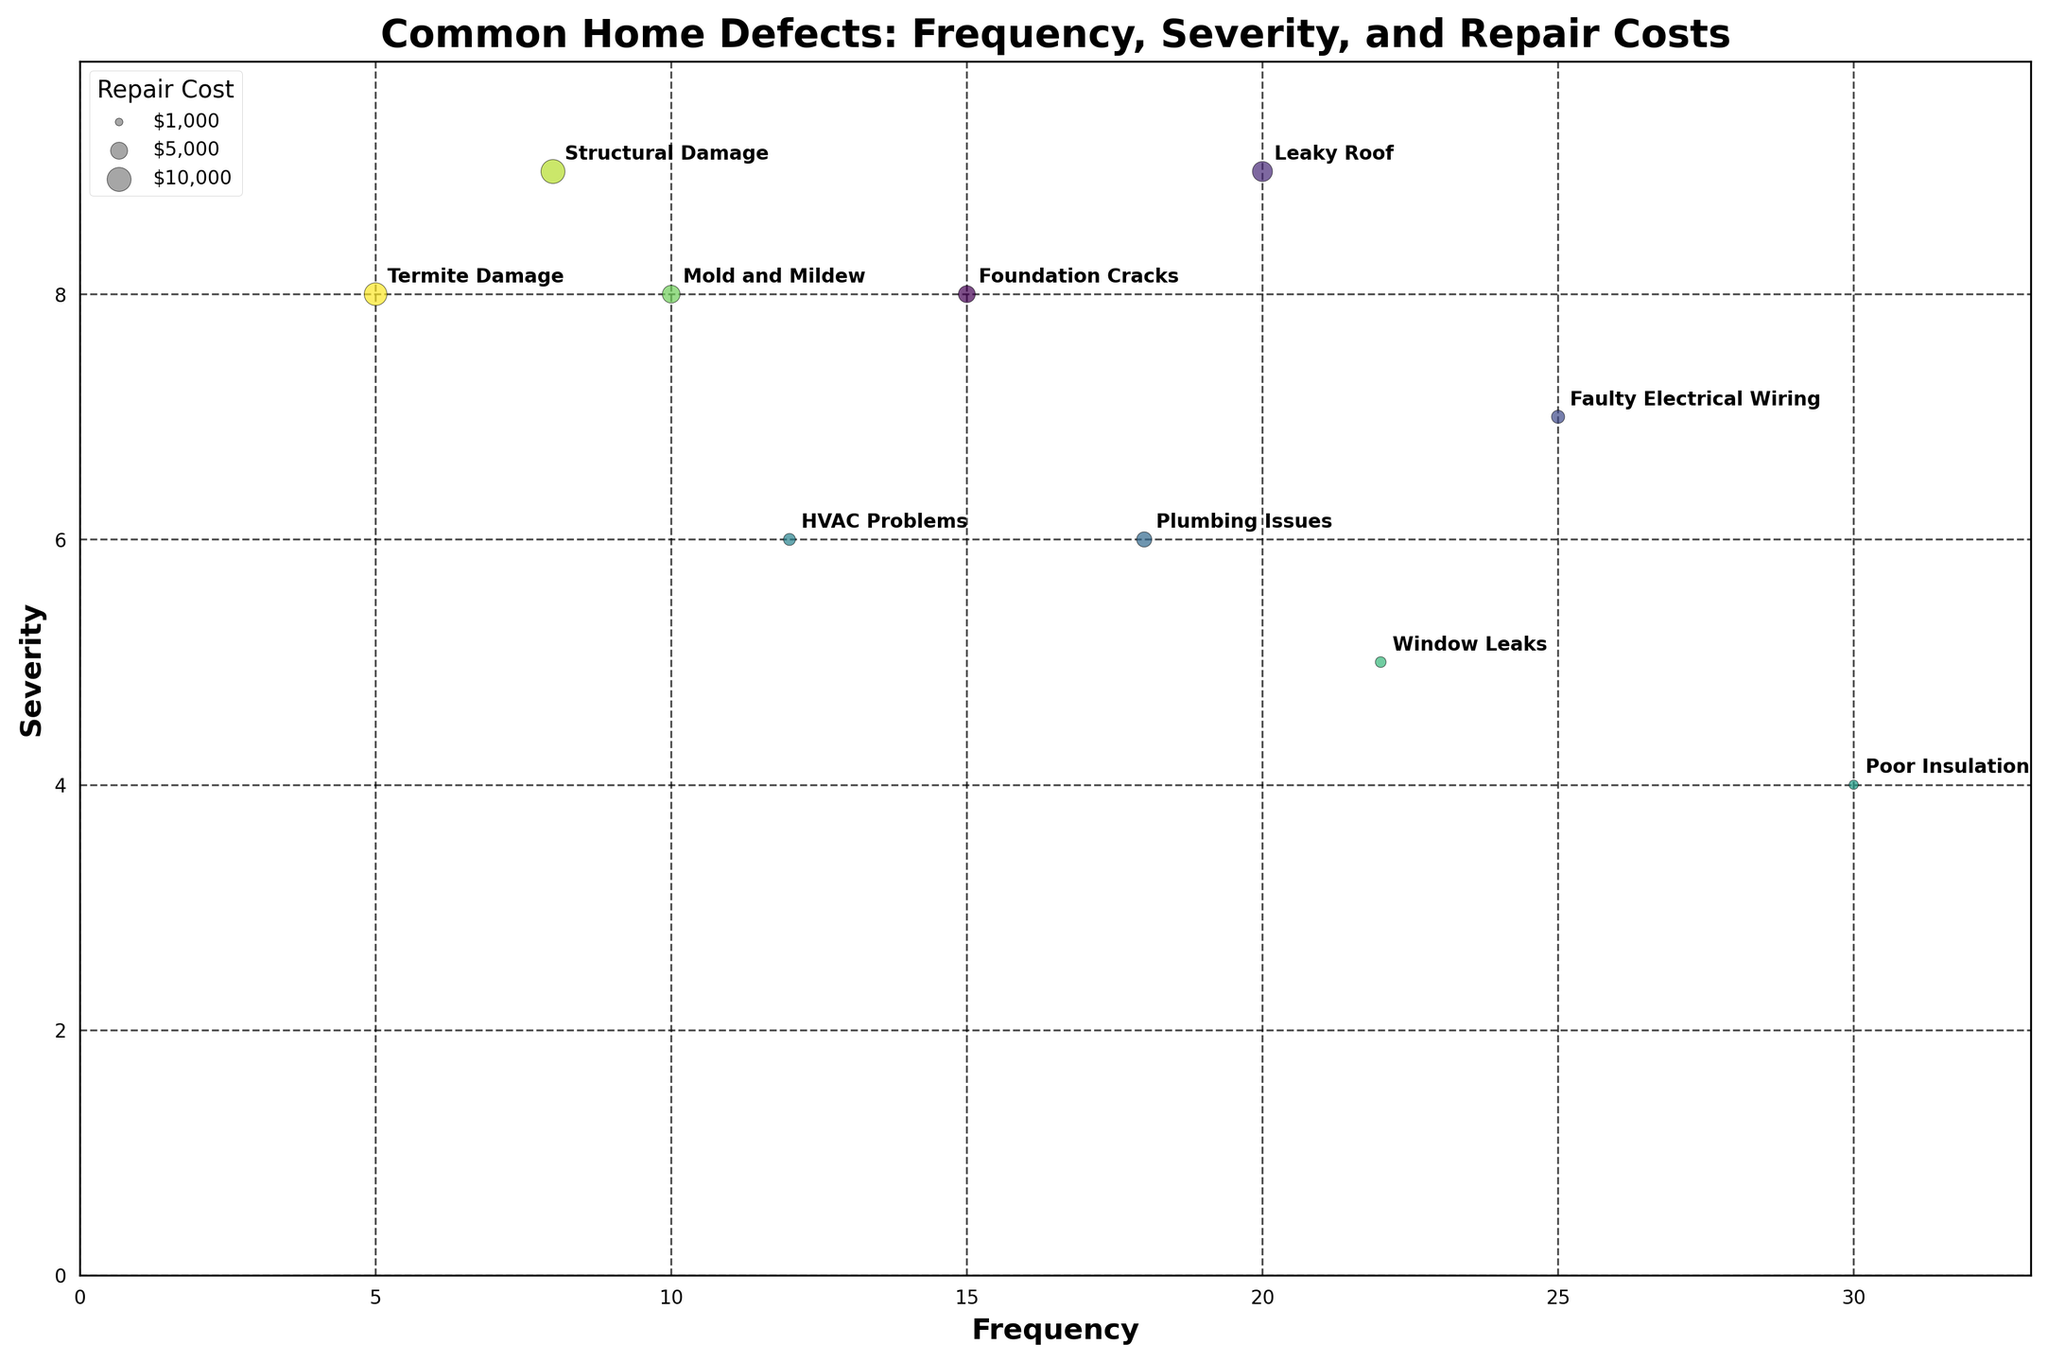How many defects are listed in the chart? To determine the number of defects listed, count the different labeled bubbles on the chart.
Answer: 10 Which home defect has the highest frequency? Look at the x-axis which represents frequency, and identify which defect is positioned furthest to the right.
Answer: Poor Insulation Which defect has the highest severity but a lower frequency than 'Leaky Roof'? Locate the 'Leaky Roof' bubble on the chart. Then, look for the highest positioned bubble (highest y-axis value) that is left of the 'Leaky Roof' bubble.
Answer: Structural Damage Calculate the average repair cost of 'Plumbing Issues' and 'Window Leaks'. Find the bubble sizes representing these defects. For 'Plumbing Issues', the repair cost is $4000. For 'Window Leaks', it is $2000. Average = ($4000 + $2000)/2 = $3000.
Answer: $3000 Which defect has more frequency: 'Faulty Electrical Wiring' or 'Foundation Cracks'? Compare the x-axis values of 'Faulty Electrical Wiring' and 'Foundation Cracks'. The one further to the right has higher frequency.
Answer: Faulty Electrical Wiring Based on severity, which defect needs more urgent repair: 'HVAC Problems' or 'Mold and Mildew'? Compare the y-axis positions of 'HVAC Problems' and 'Mold and Mildew'. The one higher up represents higher severity.
Answer: Mold and Mildew What is the bubble size representing the highest repair cost in the chart? Identify the largest bubble on the chart. The largest bubble represents 'Structural Damage' with a repair cost of $10,000.
Answer: $10,000 How much higher is the repair cost of 'Termite Damage' compared to 'Poor Insulation'? Find the repair costs of both defects. 'Termite Damage' has $9000 and 'Poor Insulation' has $1500. Difference = $9000 - $1500 = $7500.
Answer: $7500 What's the repair cost difference between 'Leaky Roof' and 'Foundation Cracks'? Find the repair costs for these defects. 'Leaky Roof' is $7000, and 'Foundation Cracks' is $5000. Difference = $7000 - $5000 = $2000.
Answer: $2000 Which defect might be considered less urgent even if it occurs frequently? Identify the bubble with high frequency but low on the severity (y-axis). 'Poor Insulation' occurs frequently (highest on x-axis) but has lower severity.
Answer: Poor Insulation 